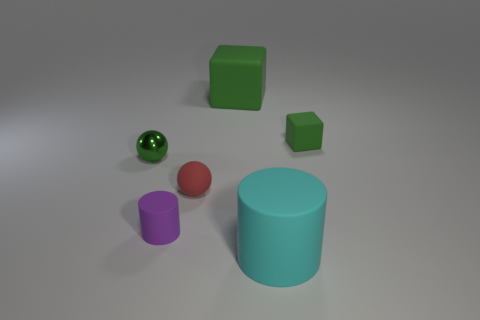Add 2 metallic spheres. How many objects exist? 8 Subtract all spheres. How many objects are left? 4 Add 3 green shiny things. How many green shiny things are left? 4 Add 6 green things. How many green things exist? 9 Subtract 0 cyan spheres. How many objects are left? 6 Subtract all blocks. Subtract all tiny cylinders. How many objects are left? 3 